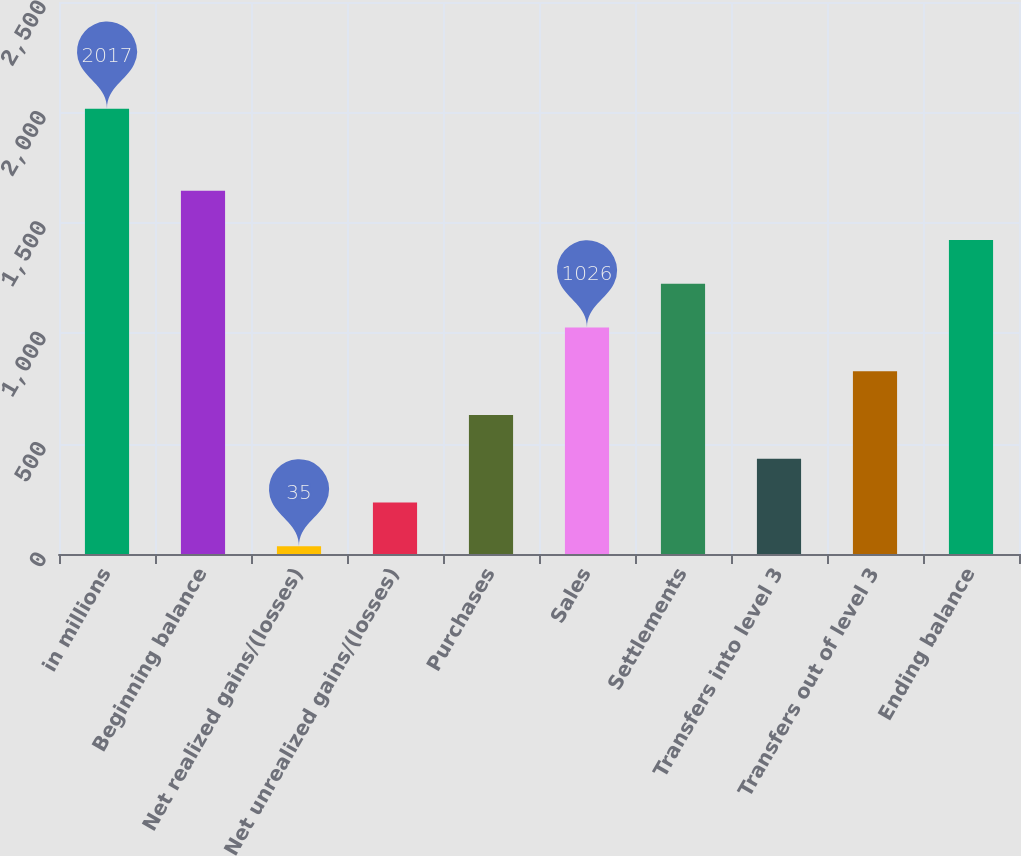<chart> <loc_0><loc_0><loc_500><loc_500><bar_chart><fcel>in millions<fcel>Beginning balance<fcel>Net realized gains/(losses)<fcel>Net unrealized gains/(losses)<fcel>Purchases<fcel>Sales<fcel>Settlements<fcel>Transfers into level 3<fcel>Transfers out of level 3<fcel>Ending balance<nl><fcel>2017<fcel>1645<fcel>35<fcel>233.2<fcel>629.6<fcel>1026<fcel>1224.2<fcel>431.4<fcel>827.8<fcel>1422.4<nl></chart> 